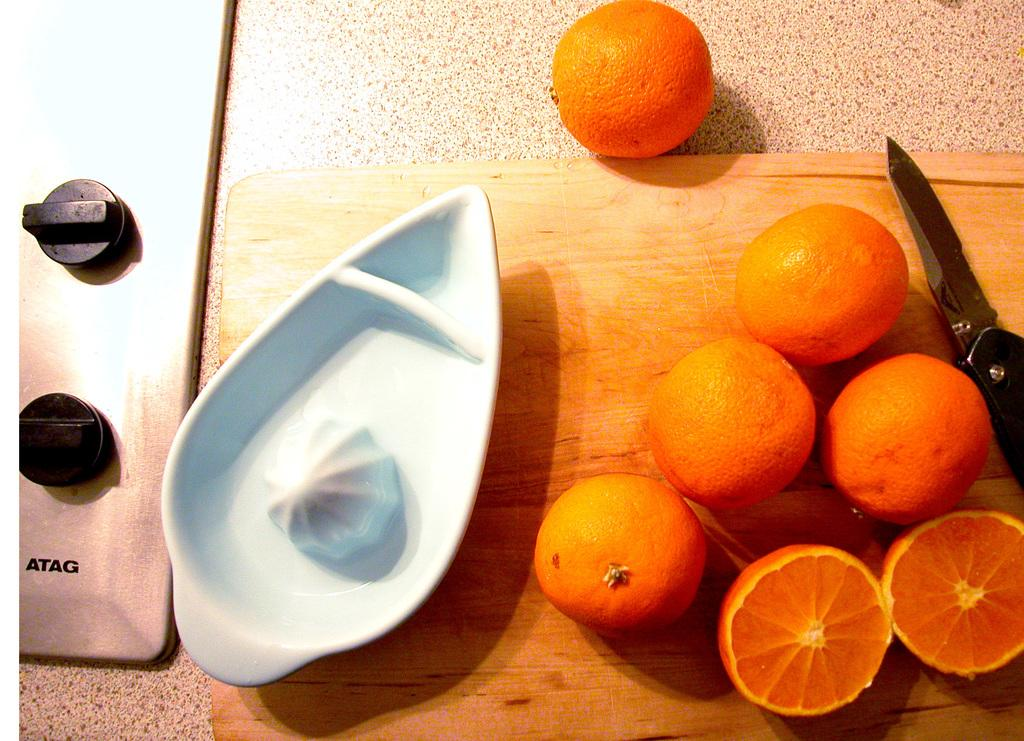What is on the surface in the image? There is a cutting board on the surface in the image. What is on the cutting board? There is a knife, a bowl, and oranges on the cutting board. What might be used for cutting in the image? The knife on the cutting board might be used for cutting. What is the purpose of the bowl on the cutting board? The bowl on the cutting board might be used for collecting the cut oranges. What is the man's reaction to the island in the image? There is no man or island present in the image. 